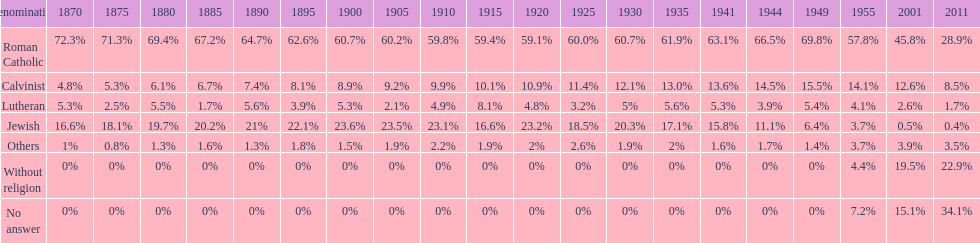Which denomination percentage increased the most after 1949? Without religion. 